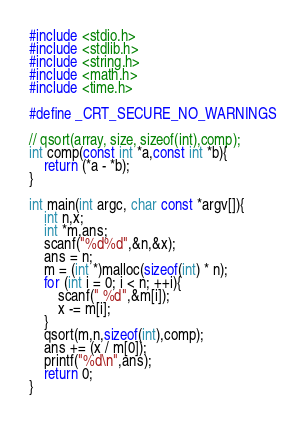<code> <loc_0><loc_0><loc_500><loc_500><_C_>#include <stdio.h>
#include <stdlib.h>
#include <string.h>
#include <math.h>
#include <time.h>

#define _CRT_SECURE_NO_WARNINGS

// qsort(array, size, sizeof(int),comp);
int comp(const int *a,const int *b){
	return (*a - *b);
}

int main(int argc, char const *argv[]){
	int n,x;
	int *m,ans;
	scanf("%d%d",&n,&x);
	ans = n;
	m = (int *)malloc(sizeof(int) * n);
	for (int i = 0; i < n; ++i){
		scanf(" %d",&m[i]);
		x -= m[i];
	}
	qsort(m,n,sizeof(int),comp);
	ans += (x / m[0]);
	printf("%d\n",ans);
	return 0;
}
</code> 